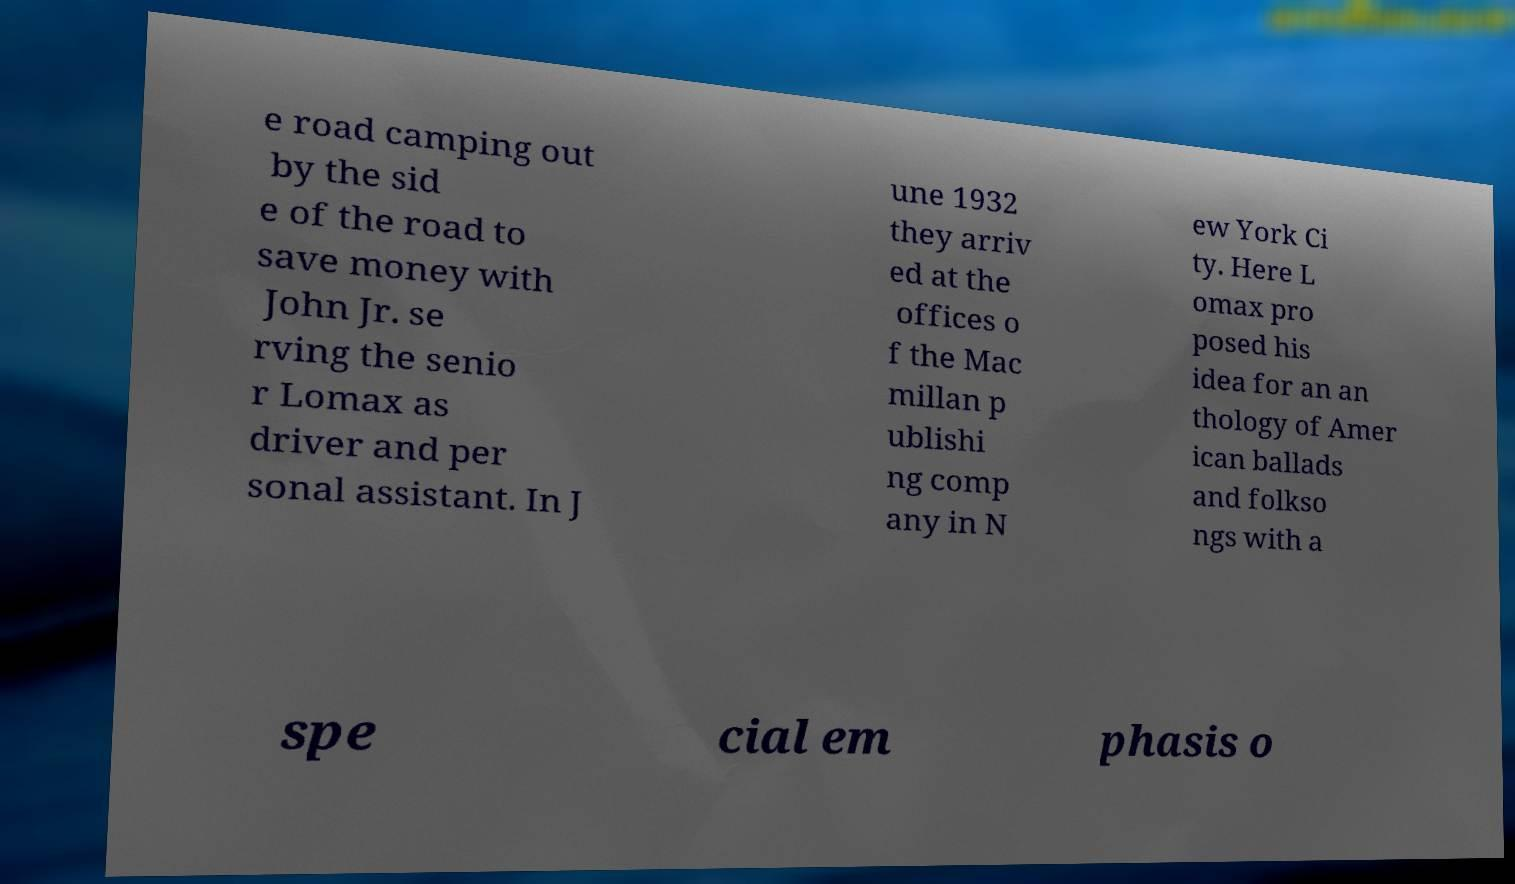Can you accurately transcribe the text from the provided image for me? e road camping out by the sid e of the road to save money with John Jr. se rving the senio r Lomax as driver and per sonal assistant. In J une 1932 they arriv ed at the offices o f the Mac millan p ublishi ng comp any in N ew York Ci ty. Here L omax pro posed his idea for an an thology of Amer ican ballads and folkso ngs with a spe cial em phasis o 